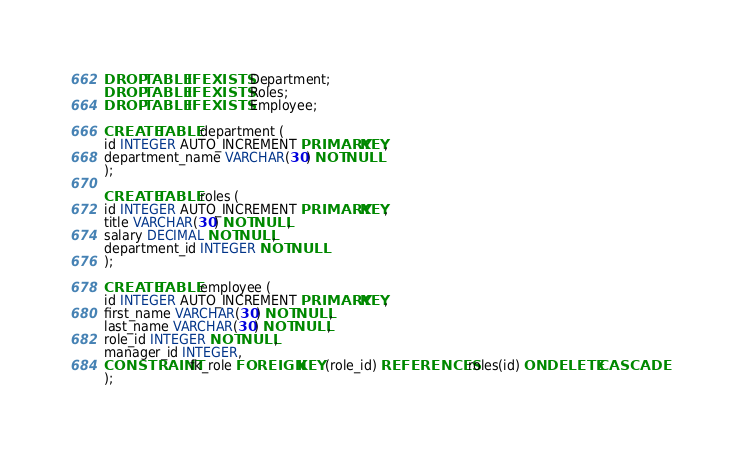Convert code to text. <code><loc_0><loc_0><loc_500><loc_500><_SQL_>DROP TABLE IF EXISTS Department;
DROP TABLE IF EXISTS Roles;
DROP TABLE IF EXISTS Employee;

CREATE TABLE department (
id INTEGER AUTO_INCREMENT PRIMARY KEY,
department_name VARCHAR(30) NOT NULL
);

CREATE TABLE roles (
id INTEGER AUTO_INCREMENT PRIMARY KEY,
title VARCHAR(30) NOT NULL,
salary DECIMAL NOT NULL,
department_id INTEGER NOT NULL
);

CREATE TABLE employee (
id INTEGER AUTO_INCREMENT PRIMARY KEY,  
first_name VARCHAR(30) NOT NULL,
last_name VARCHAR(30) NOT NULL,
role_id INTEGER NOT NULL,
manager_id INTEGER,
CONSTRAINT fk_role FOREIGN KEY (role_id) REFERENCES roles(id) ON DELETE CASCADE
);
</code> 